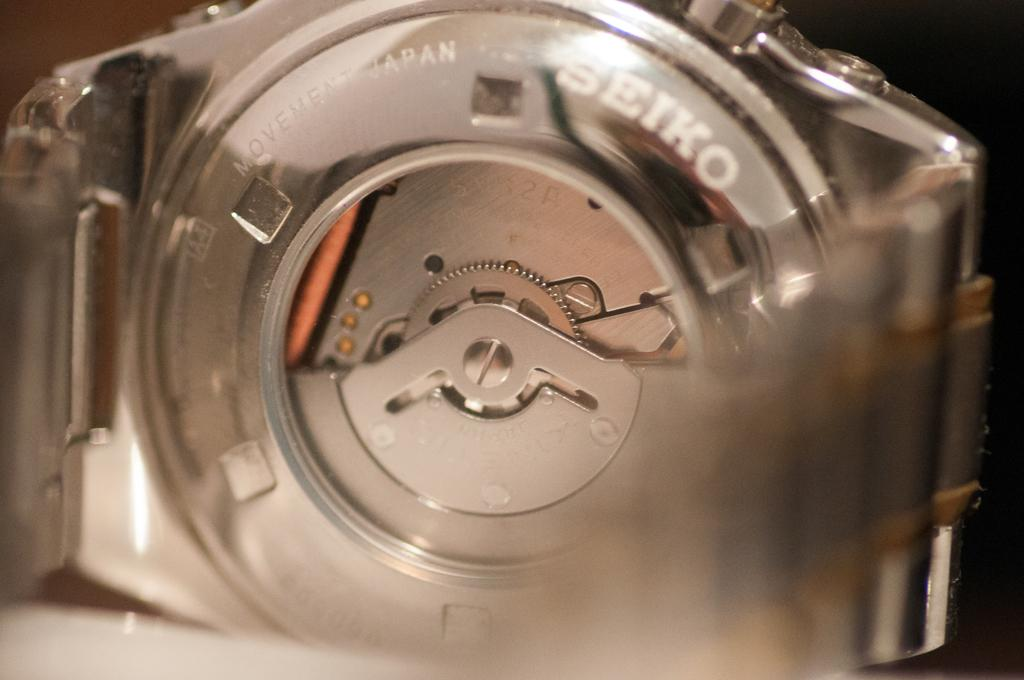<image>
Present a compact description of the photo's key features. A mechanical device with Seiko printed on it. 